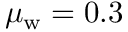Convert formula to latex. <formula><loc_0><loc_0><loc_500><loc_500>\mu _ { w } = 0 . 3</formula> 